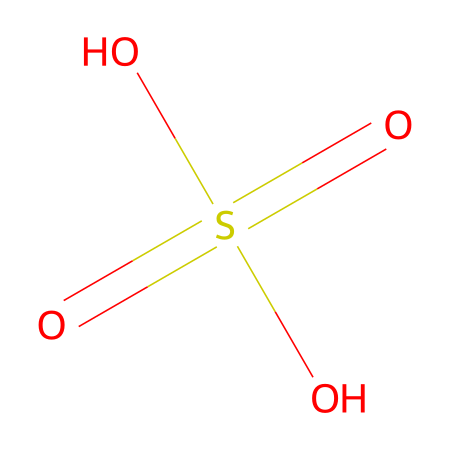What is the chemical name of this compound? The SMILES representation indicates that the compound contains sulfur with a central sulfur atom bonded to four oxygen atoms, including two double-bonded oxygens and two hydroxyl groups. This corresponds to the chemical name sulfuric acid, or more specifically, it’s known as sulfurous acid when referring to its use as a food preservative.
Answer: sulfurous acid How many oxygen atoms are present in this structure? By analyzing the SMILES representation, we can count a total of four oxygen atoms connected to the sulfur atom, two of which are double-bonded and two are in hydroxyl (OH) groups.
Answer: four How many total bonds are depicted in this chemical structure? The structure shows a sulfur atom bonded to four oxygen atoms and each hydroxyl group (OH) contributes to a bond. The two double bonds count as two bonds, and the two hydroxyl groups each provide one single bond to sulfur. Therefore, there are a total of six bonds (two double bonds and two single bonds from the hydroxyls).
Answer: six What functional groups are present in this chemical? In the analysis of the SMILES, there are two hydroxyl groups (-OH) which are indicative of alcohol functional groups. Additionally, the two double-bonded oxygens represent sulfonyl groups, thus the compound contains sulfonyl and alcohol functional groups.
Answer: sulfonyl and alcohol Why is this compound used as a food preservative? The structure reveals that the compound has strong oxidizing properties due to sulfur's ability to form multiple bonds with oxygen, which contributes to its antimicrobial effects, enabling it to inhibit bacterial growth and spoilage in foods. This is particularly useful in prolonging the shelf life of various food products.
Answer: antimicrobial effects 